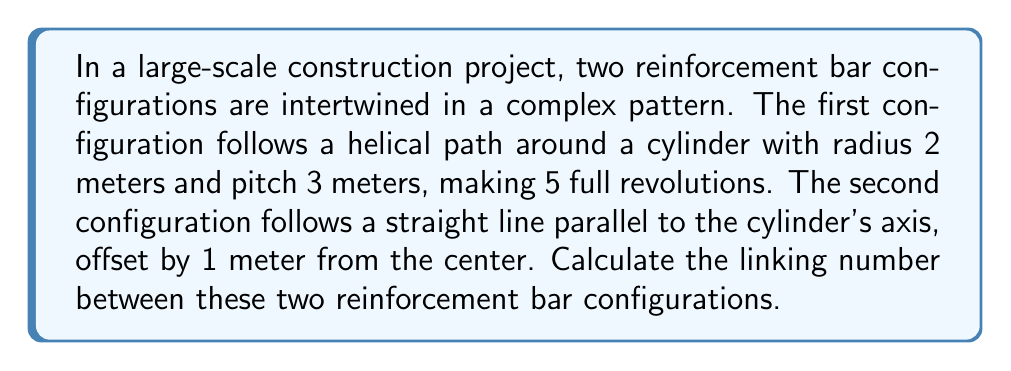Help me with this question. To calculate the linking number between these two configurations, we'll follow these steps:

1) The linking number can be calculated using the Gauss linking integral:

   $$Lk = \frac{1}{4\pi} \oint_{\gamma_1} \oint_{\gamma_2} \frac{(\mathbf{r}_1 - \mathbf{r}_2) \cdot (d\mathbf{r}_1 \times d\mathbf{r}_2)}{|\mathbf{r}_1 - \mathbf{r}_2|^3}$$

2) For a helix around a cylinder and a straight line, this simplifies to:

   $$Lk = n \cdot \frac{h}{\sqrt{h^2 + (2\pi r)^2}}$$

   Where $n$ is the number of revolutions, $h$ is the pitch, and $r$ is the radius of the helix.

3) In this case:
   $n = 5$ (number of revolutions)
   $h = 3$ meters (pitch)
   $r = 2$ meters (radius of cylinder)

4) Substituting these values:

   $$Lk = 5 \cdot \frac{3}{\sqrt{3^2 + (2\pi \cdot 2)^2}}$$

5) Simplify:
   $$Lk = 5 \cdot \frac{3}{\sqrt{9 + 16\pi^2}}$$

6) Calculate the result:
   $$Lk \approx 5 \cdot 0.2998 \approx 1.499$$

7) The linking number must be an integer, so we round to the nearest whole number:
   $$Lk = 1$$

This means the two reinforcement bar configurations are linked once.
Answer: 1 